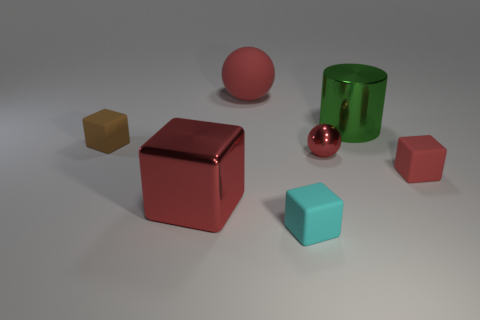Subtract all cyan cylinders. How many red blocks are left? 2 Subtract all big red blocks. How many blocks are left? 3 Subtract all brown blocks. How many blocks are left? 3 Add 1 tiny balls. How many objects exist? 8 Subtract all yellow blocks. Subtract all gray cylinders. How many blocks are left? 4 Subtract all spheres. How many objects are left? 5 Subtract all big purple shiny cubes. Subtract all red shiny spheres. How many objects are left? 6 Add 1 red cubes. How many red cubes are left? 3 Add 1 red shiny blocks. How many red shiny blocks exist? 2 Subtract 1 green cylinders. How many objects are left? 6 